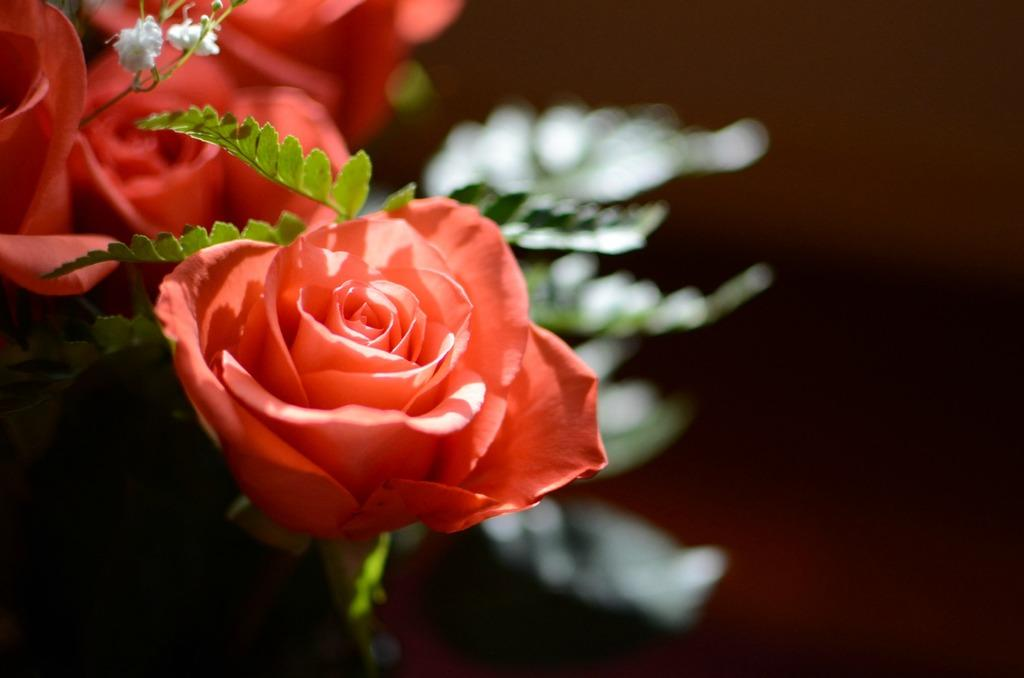What type of plants can be seen in the image? There are flowers in the image. What color are the flowers? The flowers are orange in color. Are there any other parts of the plants visible in the image? Yes, there are leaves in the image. Can you tell me where the hydrant is located in the image? There is no hydrant present in the image. What type of book is being read by the flowers in the image? There are no books or reading activities depicted in the image, as it features flowers and leaves. 